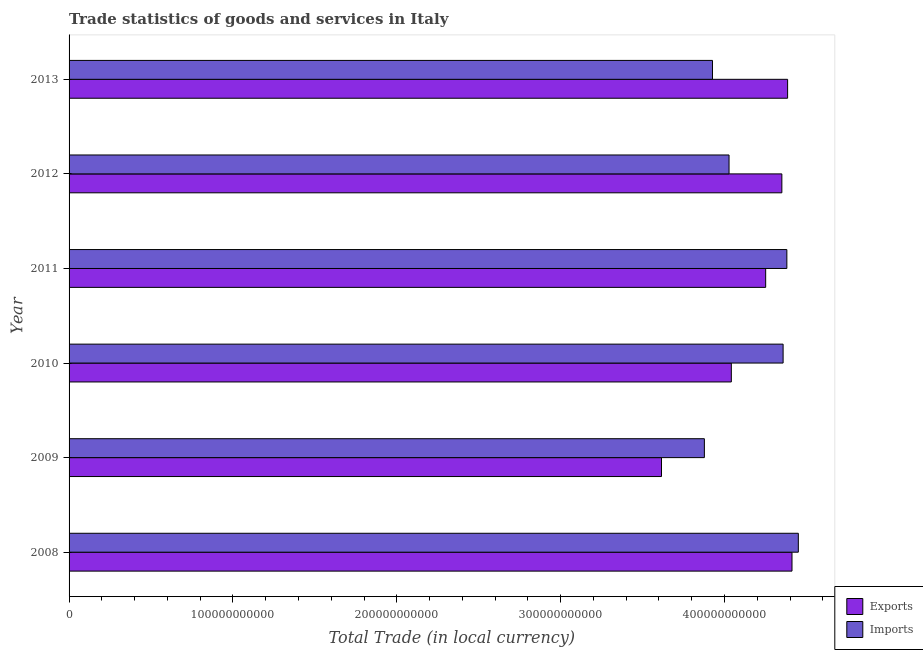How many different coloured bars are there?
Make the answer very short. 2. Are the number of bars per tick equal to the number of legend labels?
Offer a terse response. Yes. How many bars are there on the 1st tick from the bottom?
Your answer should be very brief. 2. What is the label of the 3rd group of bars from the top?
Offer a terse response. 2011. In how many cases, is the number of bars for a given year not equal to the number of legend labels?
Ensure brevity in your answer.  0. What is the imports of goods and services in 2008?
Make the answer very short. 4.45e+11. Across all years, what is the maximum imports of goods and services?
Provide a succinct answer. 4.45e+11. Across all years, what is the minimum imports of goods and services?
Give a very brief answer. 3.88e+11. What is the total imports of goods and services in the graph?
Keep it short and to the point. 2.50e+12. What is the difference between the imports of goods and services in 2008 and that in 2010?
Your response must be concise. 9.29e+09. What is the difference between the export of goods and services in 2013 and the imports of goods and services in 2012?
Provide a succinct answer. 3.57e+1. What is the average imports of goods and services per year?
Offer a very short reply. 4.17e+11. In the year 2013, what is the difference between the export of goods and services and imports of goods and services?
Give a very brief answer. 4.58e+1. In how many years, is the imports of goods and services greater than 360000000000 LCU?
Make the answer very short. 6. What is the ratio of the imports of goods and services in 2008 to that in 2010?
Your answer should be compact. 1.02. Is the imports of goods and services in 2009 less than that in 2013?
Keep it short and to the point. Yes. What is the difference between the highest and the second highest export of goods and services?
Offer a terse response. 2.68e+09. What is the difference between the highest and the lowest export of goods and services?
Provide a succinct answer. 7.96e+1. In how many years, is the export of goods and services greater than the average export of goods and services taken over all years?
Ensure brevity in your answer.  4. What does the 2nd bar from the top in 2011 represents?
Give a very brief answer. Exports. What does the 2nd bar from the bottom in 2009 represents?
Offer a terse response. Imports. How many years are there in the graph?
Your answer should be very brief. 6. What is the difference between two consecutive major ticks on the X-axis?
Offer a very short reply. 1.00e+11. Are the values on the major ticks of X-axis written in scientific E-notation?
Keep it short and to the point. No. Does the graph contain any zero values?
Provide a short and direct response. No. Where does the legend appear in the graph?
Your answer should be compact. Bottom right. How many legend labels are there?
Offer a very short reply. 2. What is the title of the graph?
Your answer should be very brief. Trade statistics of goods and services in Italy. What is the label or title of the X-axis?
Your answer should be compact. Total Trade (in local currency). What is the label or title of the Y-axis?
Your response must be concise. Year. What is the Total Trade (in local currency) in Exports in 2008?
Give a very brief answer. 4.41e+11. What is the Total Trade (in local currency) in Imports in 2008?
Ensure brevity in your answer.  4.45e+11. What is the Total Trade (in local currency) of Exports in 2009?
Offer a terse response. 3.62e+11. What is the Total Trade (in local currency) of Imports in 2009?
Ensure brevity in your answer.  3.88e+11. What is the Total Trade (in local currency) in Exports in 2010?
Your response must be concise. 4.04e+11. What is the Total Trade (in local currency) of Imports in 2010?
Offer a terse response. 4.36e+11. What is the Total Trade (in local currency) in Exports in 2011?
Keep it short and to the point. 4.25e+11. What is the Total Trade (in local currency) of Imports in 2011?
Ensure brevity in your answer.  4.38e+11. What is the Total Trade (in local currency) in Exports in 2012?
Offer a terse response. 4.35e+11. What is the Total Trade (in local currency) of Imports in 2012?
Your response must be concise. 4.03e+11. What is the Total Trade (in local currency) in Exports in 2013?
Offer a very short reply. 4.38e+11. What is the Total Trade (in local currency) of Imports in 2013?
Keep it short and to the point. 3.93e+11. Across all years, what is the maximum Total Trade (in local currency) in Exports?
Provide a succinct answer. 4.41e+11. Across all years, what is the maximum Total Trade (in local currency) of Imports?
Your answer should be very brief. 4.45e+11. Across all years, what is the minimum Total Trade (in local currency) of Exports?
Your answer should be very brief. 3.62e+11. Across all years, what is the minimum Total Trade (in local currency) in Imports?
Your answer should be compact. 3.88e+11. What is the total Total Trade (in local currency) in Exports in the graph?
Ensure brevity in your answer.  2.51e+12. What is the total Total Trade (in local currency) of Imports in the graph?
Your response must be concise. 2.50e+12. What is the difference between the Total Trade (in local currency) of Exports in 2008 and that in 2009?
Your answer should be compact. 7.96e+1. What is the difference between the Total Trade (in local currency) in Imports in 2008 and that in 2009?
Provide a short and direct response. 5.73e+1. What is the difference between the Total Trade (in local currency) in Exports in 2008 and that in 2010?
Keep it short and to the point. 3.70e+1. What is the difference between the Total Trade (in local currency) in Imports in 2008 and that in 2010?
Provide a short and direct response. 9.29e+09. What is the difference between the Total Trade (in local currency) of Exports in 2008 and that in 2011?
Your answer should be very brief. 1.61e+1. What is the difference between the Total Trade (in local currency) of Imports in 2008 and that in 2011?
Offer a very short reply. 7.00e+09. What is the difference between the Total Trade (in local currency) of Exports in 2008 and that in 2012?
Keep it short and to the point. 6.19e+09. What is the difference between the Total Trade (in local currency) in Imports in 2008 and that in 2012?
Offer a very short reply. 4.23e+1. What is the difference between the Total Trade (in local currency) of Exports in 2008 and that in 2013?
Offer a very short reply. 2.68e+09. What is the difference between the Total Trade (in local currency) in Imports in 2008 and that in 2013?
Keep it short and to the point. 5.24e+1. What is the difference between the Total Trade (in local currency) in Exports in 2009 and that in 2010?
Give a very brief answer. -4.26e+1. What is the difference between the Total Trade (in local currency) of Imports in 2009 and that in 2010?
Offer a terse response. -4.80e+1. What is the difference between the Total Trade (in local currency) of Exports in 2009 and that in 2011?
Ensure brevity in your answer.  -6.36e+1. What is the difference between the Total Trade (in local currency) in Imports in 2009 and that in 2011?
Your response must be concise. -5.03e+1. What is the difference between the Total Trade (in local currency) of Exports in 2009 and that in 2012?
Offer a very short reply. -7.34e+1. What is the difference between the Total Trade (in local currency) of Imports in 2009 and that in 2012?
Your response must be concise. -1.51e+1. What is the difference between the Total Trade (in local currency) in Exports in 2009 and that in 2013?
Offer a very short reply. -7.70e+1. What is the difference between the Total Trade (in local currency) in Imports in 2009 and that in 2013?
Offer a very short reply. -4.95e+09. What is the difference between the Total Trade (in local currency) in Exports in 2010 and that in 2011?
Keep it short and to the point. -2.10e+1. What is the difference between the Total Trade (in local currency) in Imports in 2010 and that in 2011?
Ensure brevity in your answer.  -2.29e+09. What is the difference between the Total Trade (in local currency) in Exports in 2010 and that in 2012?
Your answer should be very brief. -3.08e+1. What is the difference between the Total Trade (in local currency) in Imports in 2010 and that in 2012?
Make the answer very short. 3.30e+1. What is the difference between the Total Trade (in local currency) in Exports in 2010 and that in 2013?
Provide a short and direct response. -3.43e+1. What is the difference between the Total Trade (in local currency) of Imports in 2010 and that in 2013?
Your answer should be very brief. 4.31e+1. What is the difference between the Total Trade (in local currency) of Exports in 2011 and that in 2012?
Give a very brief answer. -9.88e+09. What is the difference between the Total Trade (in local currency) in Imports in 2011 and that in 2012?
Keep it short and to the point. 3.53e+1. What is the difference between the Total Trade (in local currency) in Exports in 2011 and that in 2013?
Keep it short and to the point. -1.34e+1. What is the difference between the Total Trade (in local currency) in Imports in 2011 and that in 2013?
Your answer should be very brief. 4.54e+1. What is the difference between the Total Trade (in local currency) in Exports in 2012 and that in 2013?
Provide a succinct answer. -3.51e+09. What is the difference between the Total Trade (in local currency) in Imports in 2012 and that in 2013?
Your response must be concise. 1.01e+1. What is the difference between the Total Trade (in local currency) of Exports in 2008 and the Total Trade (in local currency) of Imports in 2009?
Your answer should be very brief. 5.35e+1. What is the difference between the Total Trade (in local currency) in Exports in 2008 and the Total Trade (in local currency) in Imports in 2010?
Keep it short and to the point. 5.43e+09. What is the difference between the Total Trade (in local currency) of Exports in 2008 and the Total Trade (in local currency) of Imports in 2011?
Your response must be concise. 3.13e+09. What is the difference between the Total Trade (in local currency) of Exports in 2008 and the Total Trade (in local currency) of Imports in 2012?
Offer a terse response. 3.84e+1. What is the difference between the Total Trade (in local currency) of Exports in 2008 and the Total Trade (in local currency) of Imports in 2013?
Make the answer very short. 4.85e+1. What is the difference between the Total Trade (in local currency) in Exports in 2009 and the Total Trade (in local currency) in Imports in 2010?
Keep it short and to the point. -7.42e+1. What is the difference between the Total Trade (in local currency) in Exports in 2009 and the Total Trade (in local currency) in Imports in 2011?
Your answer should be very brief. -7.65e+1. What is the difference between the Total Trade (in local currency) in Exports in 2009 and the Total Trade (in local currency) in Imports in 2012?
Your answer should be very brief. -4.12e+1. What is the difference between the Total Trade (in local currency) of Exports in 2009 and the Total Trade (in local currency) of Imports in 2013?
Offer a terse response. -3.11e+1. What is the difference between the Total Trade (in local currency) in Exports in 2010 and the Total Trade (in local currency) in Imports in 2011?
Ensure brevity in your answer.  -3.39e+1. What is the difference between the Total Trade (in local currency) in Exports in 2010 and the Total Trade (in local currency) in Imports in 2012?
Give a very brief answer. 1.39e+09. What is the difference between the Total Trade (in local currency) of Exports in 2010 and the Total Trade (in local currency) of Imports in 2013?
Offer a terse response. 1.15e+1. What is the difference between the Total Trade (in local currency) in Exports in 2011 and the Total Trade (in local currency) in Imports in 2012?
Make the answer very short. 2.24e+1. What is the difference between the Total Trade (in local currency) in Exports in 2011 and the Total Trade (in local currency) in Imports in 2013?
Keep it short and to the point. 3.25e+1. What is the difference between the Total Trade (in local currency) of Exports in 2012 and the Total Trade (in local currency) of Imports in 2013?
Offer a terse response. 4.23e+1. What is the average Total Trade (in local currency) in Exports per year?
Offer a very short reply. 4.18e+11. What is the average Total Trade (in local currency) of Imports per year?
Your answer should be very brief. 4.17e+11. In the year 2008, what is the difference between the Total Trade (in local currency) of Exports and Total Trade (in local currency) of Imports?
Your answer should be compact. -3.86e+09. In the year 2009, what is the difference between the Total Trade (in local currency) in Exports and Total Trade (in local currency) in Imports?
Offer a terse response. -2.62e+1. In the year 2010, what is the difference between the Total Trade (in local currency) of Exports and Total Trade (in local currency) of Imports?
Offer a very short reply. -3.16e+1. In the year 2011, what is the difference between the Total Trade (in local currency) in Exports and Total Trade (in local currency) in Imports?
Your response must be concise. -1.29e+1. In the year 2012, what is the difference between the Total Trade (in local currency) of Exports and Total Trade (in local currency) of Imports?
Provide a succinct answer. 3.22e+1. In the year 2013, what is the difference between the Total Trade (in local currency) of Exports and Total Trade (in local currency) of Imports?
Give a very brief answer. 4.58e+1. What is the ratio of the Total Trade (in local currency) in Exports in 2008 to that in 2009?
Give a very brief answer. 1.22. What is the ratio of the Total Trade (in local currency) in Imports in 2008 to that in 2009?
Provide a succinct answer. 1.15. What is the ratio of the Total Trade (in local currency) in Exports in 2008 to that in 2010?
Offer a terse response. 1.09. What is the ratio of the Total Trade (in local currency) in Imports in 2008 to that in 2010?
Your answer should be compact. 1.02. What is the ratio of the Total Trade (in local currency) of Exports in 2008 to that in 2011?
Offer a very short reply. 1.04. What is the ratio of the Total Trade (in local currency) in Exports in 2008 to that in 2012?
Your answer should be compact. 1.01. What is the ratio of the Total Trade (in local currency) in Imports in 2008 to that in 2012?
Keep it short and to the point. 1.1. What is the ratio of the Total Trade (in local currency) of Imports in 2008 to that in 2013?
Offer a very short reply. 1.13. What is the ratio of the Total Trade (in local currency) in Exports in 2009 to that in 2010?
Make the answer very short. 0.89. What is the ratio of the Total Trade (in local currency) of Imports in 2009 to that in 2010?
Your answer should be very brief. 0.89. What is the ratio of the Total Trade (in local currency) in Exports in 2009 to that in 2011?
Make the answer very short. 0.85. What is the ratio of the Total Trade (in local currency) in Imports in 2009 to that in 2011?
Provide a short and direct response. 0.89. What is the ratio of the Total Trade (in local currency) in Exports in 2009 to that in 2012?
Give a very brief answer. 0.83. What is the ratio of the Total Trade (in local currency) of Imports in 2009 to that in 2012?
Keep it short and to the point. 0.96. What is the ratio of the Total Trade (in local currency) of Exports in 2009 to that in 2013?
Offer a very short reply. 0.82. What is the ratio of the Total Trade (in local currency) of Imports in 2009 to that in 2013?
Your response must be concise. 0.99. What is the ratio of the Total Trade (in local currency) of Exports in 2010 to that in 2011?
Make the answer very short. 0.95. What is the ratio of the Total Trade (in local currency) in Exports in 2010 to that in 2012?
Ensure brevity in your answer.  0.93. What is the ratio of the Total Trade (in local currency) in Imports in 2010 to that in 2012?
Ensure brevity in your answer.  1.08. What is the ratio of the Total Trade (in local currency) in Exports in 2010 to that in 2013?
Keep it short and to the point. 0.92. What is the ratio of the Total Trade (in local currency) of Imports in 2010 to that in 2013?
Your response must be concise. 1.11. What is the ratio of the Total Trade (in local currency) of Exports in 2011 to that in 2012?
Give a very brief answer. 0.98. What is the ratio of the Total Trade (in local currency) of Imports in 2011 to that in 2012?
Keep it short and to the point. 1.09. What is the ratio of the Total Trade (in local currency) in Exports in 2011 to that in 2013?
Your response must be concise. 0.97. What is the ratio of the Total Trade (in local currency) of Imports in 2011 to that in 2013?
Offer a very short reply. 1.12. What is the ratio of the Total Trade (in local currency) of Imports in 2012 to that in 2013?
Your answer should be very brief. 1.03. What is the difference between the highest and the second highest Total Trade (in local currency) of Exports?
Provide a short and direct response. 2.68e+09. What is the difference between the highest and the second highest Total Trade (in local currency) of Imports?
Make the answer very short. 7.00e+09. What is the difference between the highest and the lowest Total Trade (in local currency) of Exports?
Your response must be concise. 7.96e+1. What is the difference between the highest and the lowest Total Trade (in local currency) of Imports?
Offer a terse response. 5.73e+1. 